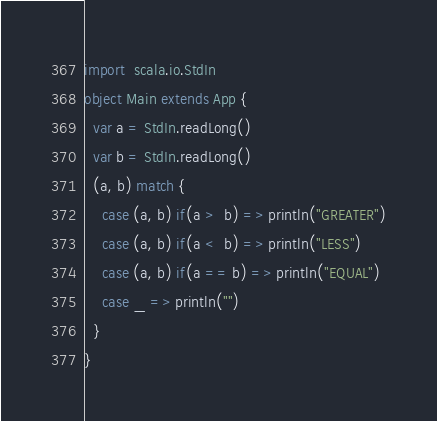<code> <loc_0><loc_0><loc_500><loc_500><_Scala_>import  scala.io.StdIn
object Main extends App {
  var a = StdIn.readLong()
  var b = StdIn.readLong()
  (a, b) match {
    case (a, b) if(a >  b) => println("GREATER")
    case (a, b) if(a <  b) => println("LESS")
    case (a, b) if(a == b) => println("EQUAL")
    case _ => println("")
  }
}
</code> 